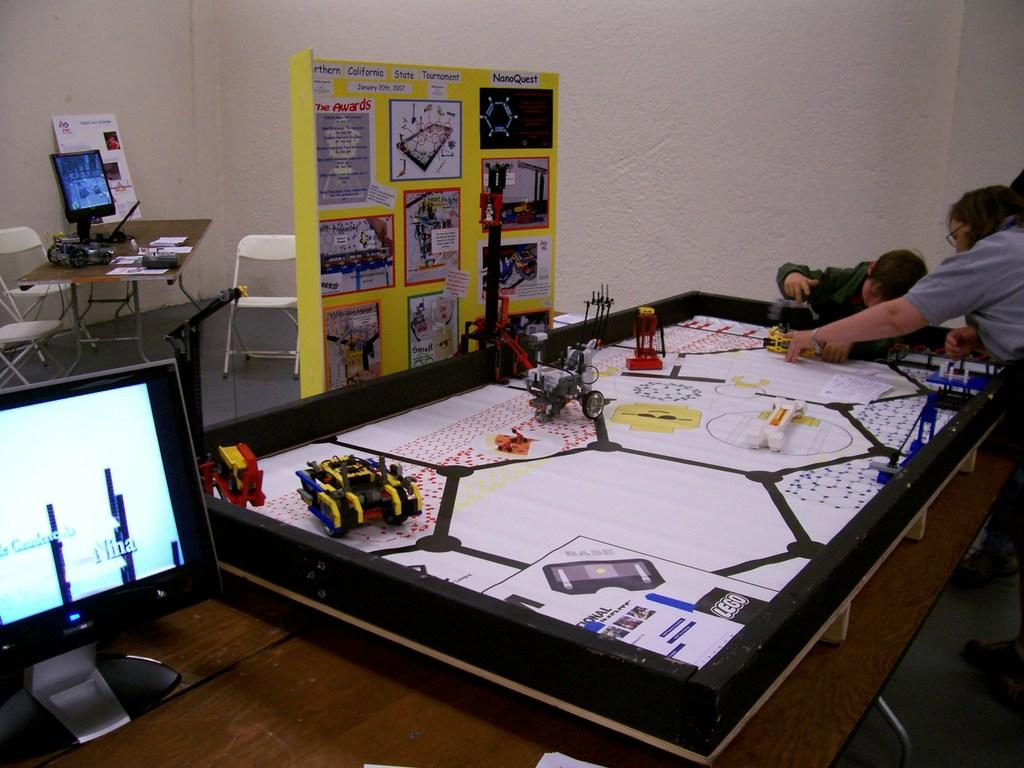Who or what can be seen in the image? There are people in the image. What objects are on the table in the image? There are soft toys on a table. What electronic device is visible in the image? There is a monitor in the image. What furniture can be seen in the background of the image? In the background, there are chairs and another table. Are there any other electronic devices in the image? Yes, there is another monitor in the background. What type of ornament is hanging from the ceiling in the image? There is no ornament hanging from the ceiling in the image. How does the growth of the plants in the image contribute to the overall aesthetic? There are no plants present in the image, so their growth cannot contribute to the overall aesthetic. 